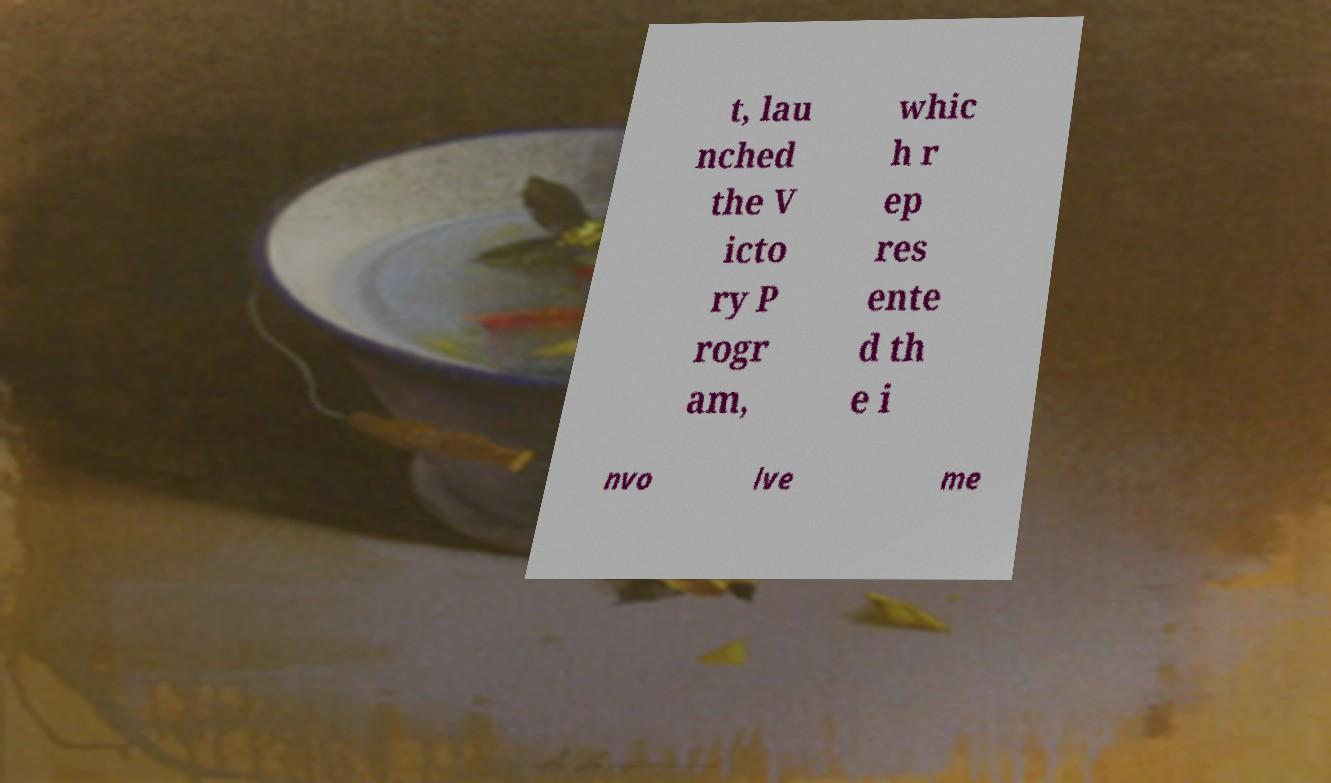Please identify and transcribe the text found in this image. t, lau nched the V icto ry P rogr am, whic h r ep res ente d th e i nvo lve me 